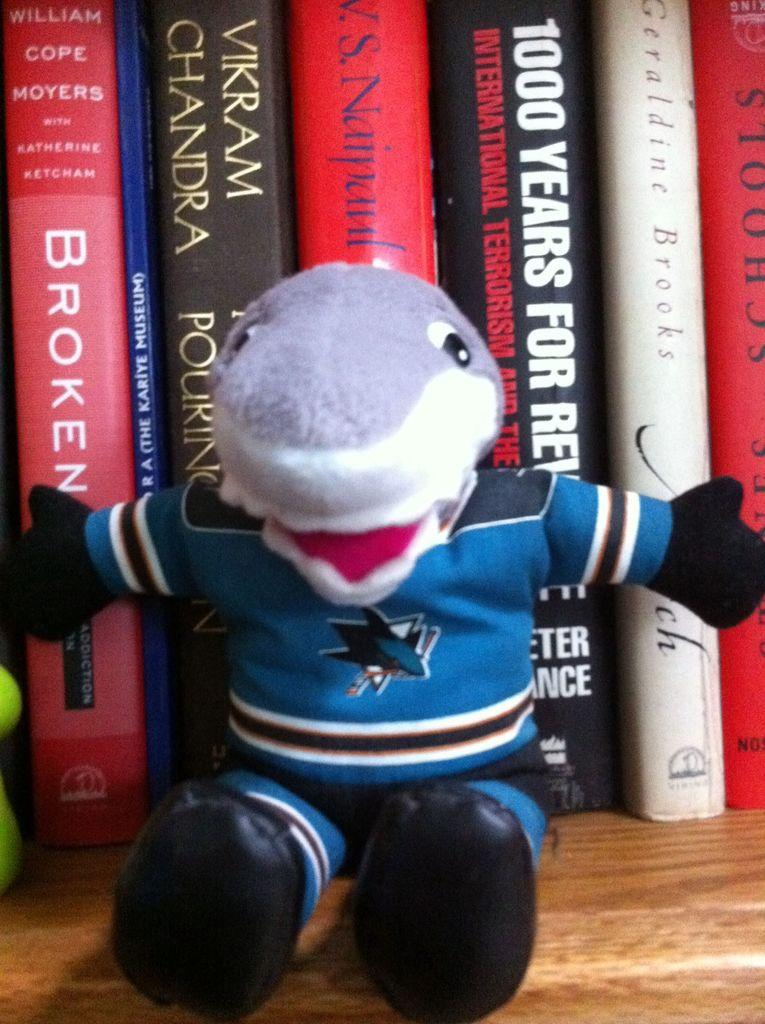<image>
Create a compact narrative representing the image presented. A shark doll sitting in front of a bunch of books, the book behind it says 1000 Years. 